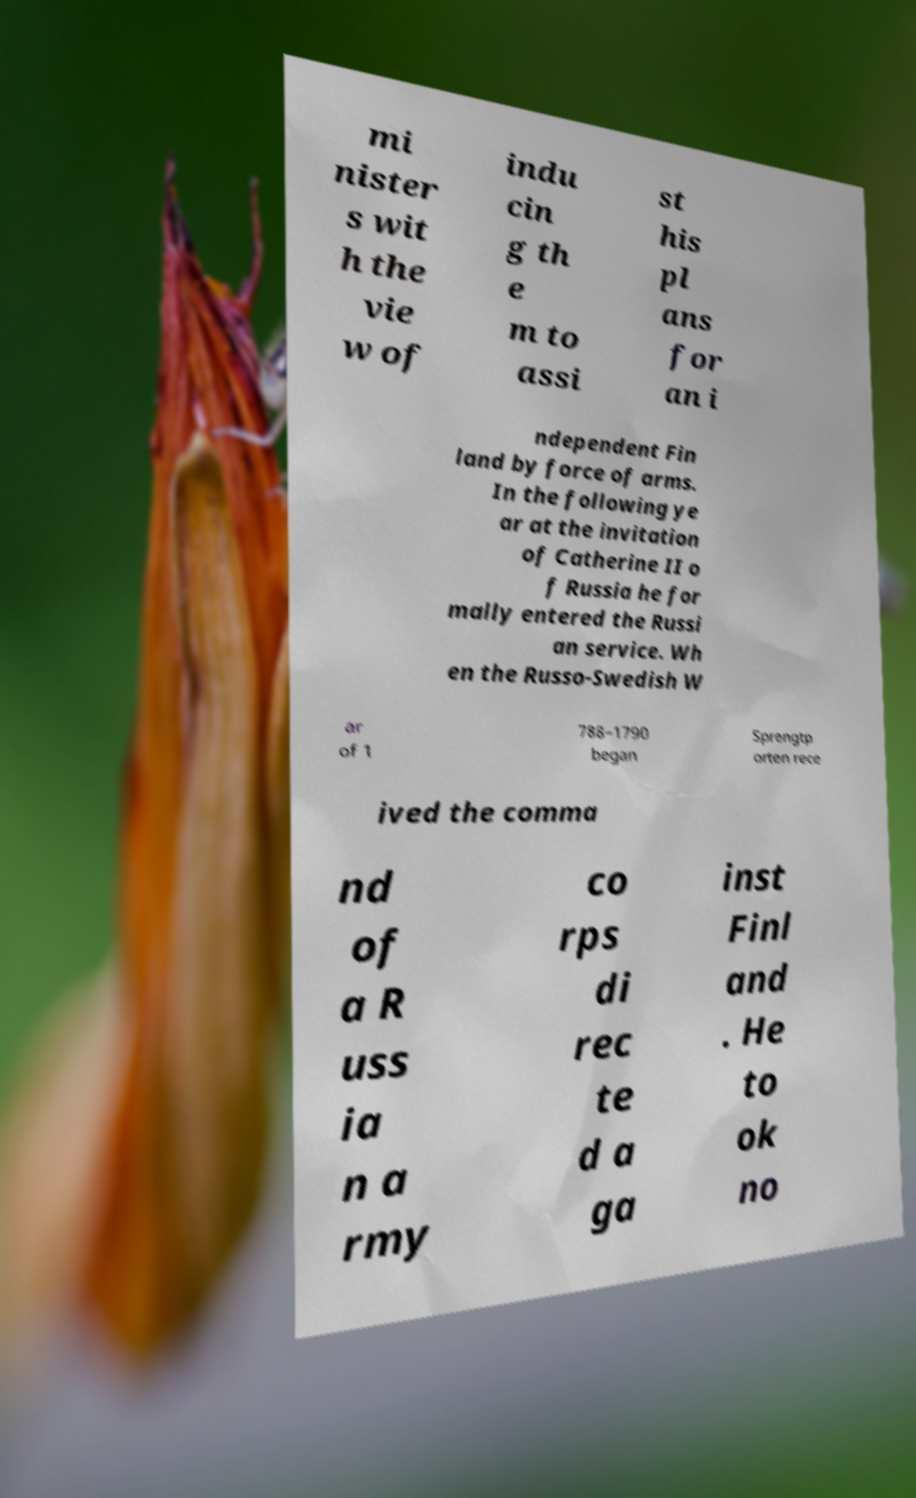Could you assist in decoding the text presented in this image and type it out clearly? mi nister s wit h the vie w of indu cin g th e m to assi st his pl ans for an i ndependent Fin land by force of arms. In the following ye ar at the invitation of Catherine II o f Russia he for mally entered the Russi an service. Wh en the Russo-Swedish W ar of 1 788–1790 began Sprengtp orten rece ived the comma nd of a R uss ia n a rmy co rps di rec te d a ga inst Finl and . He to ok no 